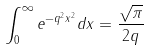Convert formula to latex. <formula><loc_0><loc_0><loc_500><loc_500>\int _ { 0 } ^ { \infty } e ^ { - q ^ { 2 } x ^ { 2 } } d x = \frac { \sqrt { \pi } } { 2 q }</formula> 